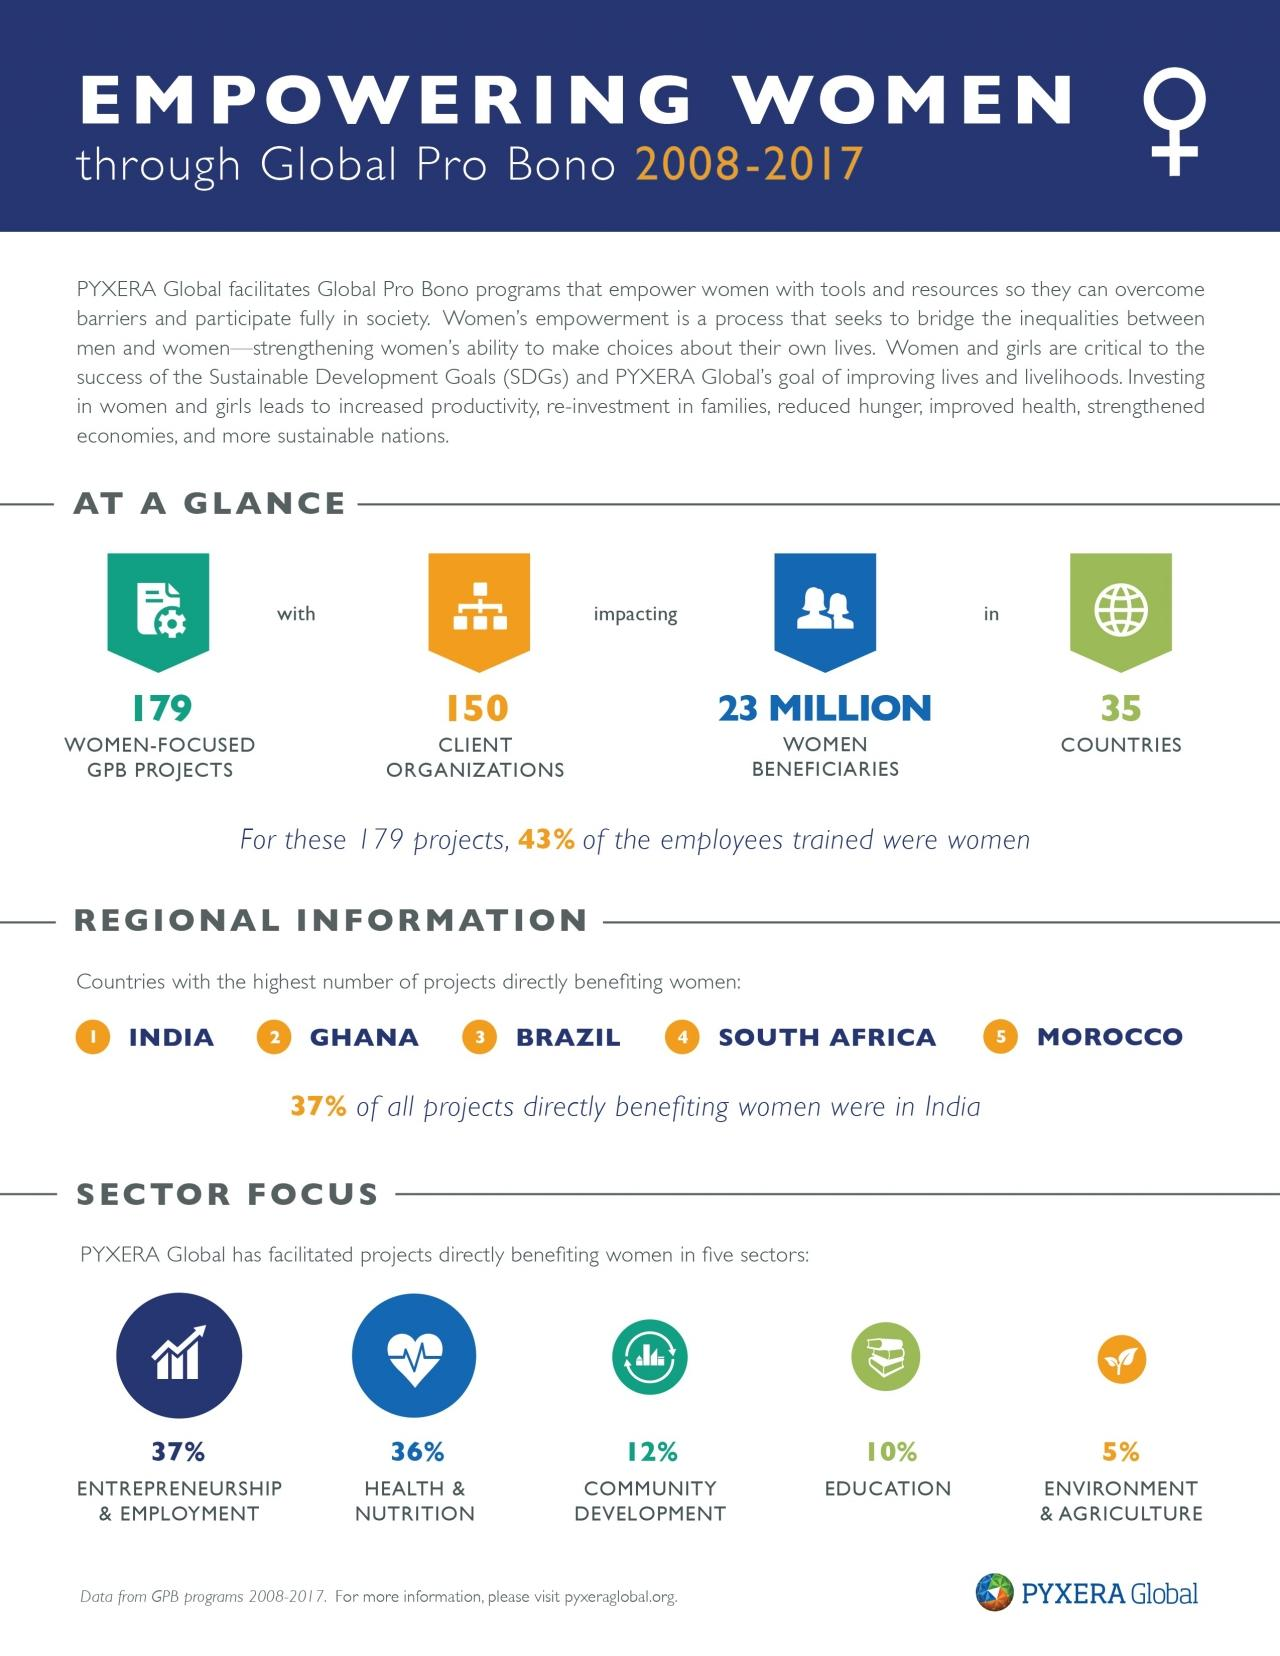Specify some key components in this picture. Ghana has the highest number of projects directly benefiting women after India from 2008 to 2017, according to data. During the 2008-2017 period, approximately 10% of PYXERA Global-facilitated projects aimed at promoting women's education. During the period of 2008 to 2017, a total of 35 countries were benefited from women-focused GPB projects. During the period of 2008-2017, PYXERA Global facilitated a total of 100 projects. Of these projects, 36% were specifically aimed at improving women's health and nutrition. 